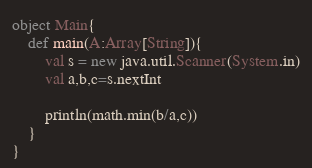Convert code to text. <code><loc_0><loc_0><loc_500><loc_500><_Scala_>object Main{
	def main(A:Array[String]){
		val s = new java.util.Scanner(System.in)
		val a,b,c=s.nextInt

		println(math.min(b/a,c))
	}
}</code> 